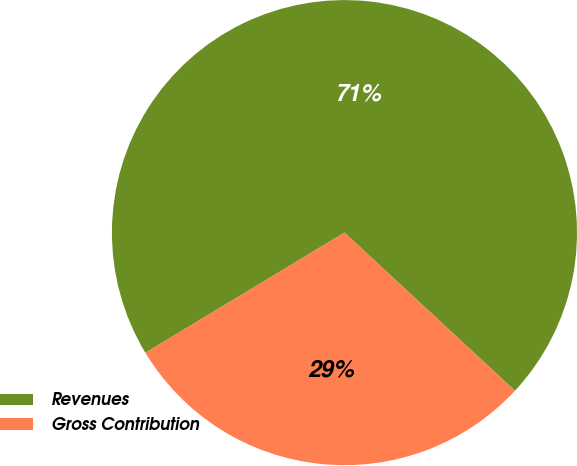Convert chart. <chart><loc_0><loc_0><loc_500><loc_500><pie_chart><fcel>Revenues<fcel>Gross Contribution<nl><fcel>70.55%<fcel>29.45%<nl></chart> 